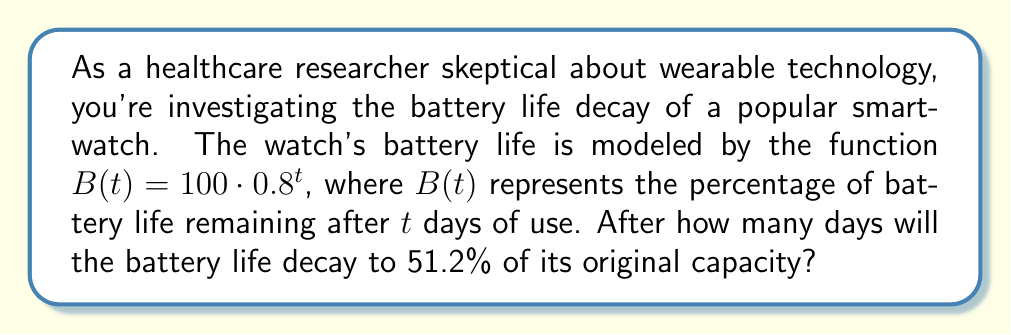Solve this math problem. To solve this problem, we need to use the properties of exponential functions and logarithms. Let's approach this step-by-step:

1) We're given the function $B(t) = 100 \cdot 0.8^t$, where $B(t)$ is the percentage of battery life remaining after $t$ days.

2) We want to find when $B(t) = 51.2\%$ of the original capacity. So, we can set up the equation:

   $100 \cdot 0.8^t = 51.2$

3) First, let's divide both sides by 100:

   $0.8^t = 0.512$

4) To solve for $t$, we need to use logarithms. We can use any base of logarithm, but since we're dealing with powers of 0.8, let's use base 0.8:

   $\log_{0.8}(0.8^t) = \log_{0.8}(0.512)$

5) The left side simplifies due to the logarithm rule $\log_a(a^x) = x$:

   $t = \log_{0.8}(0.512)$

6) To calculate this, we can use the change of base formula:

   $t = \frac{\log(0.512)}{\log(0.8)}$

7) Using a calculator (or computer):

   $t \approx 3.0000$

8) Since we're dealing with days, which are discrete units, we round up to the nearest whole number.

This decay rate demonstrates how quickly the battery life diminishes, which could be a significant concern for healthcare applications relying on consistent monitoring.
Answer: The battery life will decay to 51.2% of its original capacity after 3 days. 